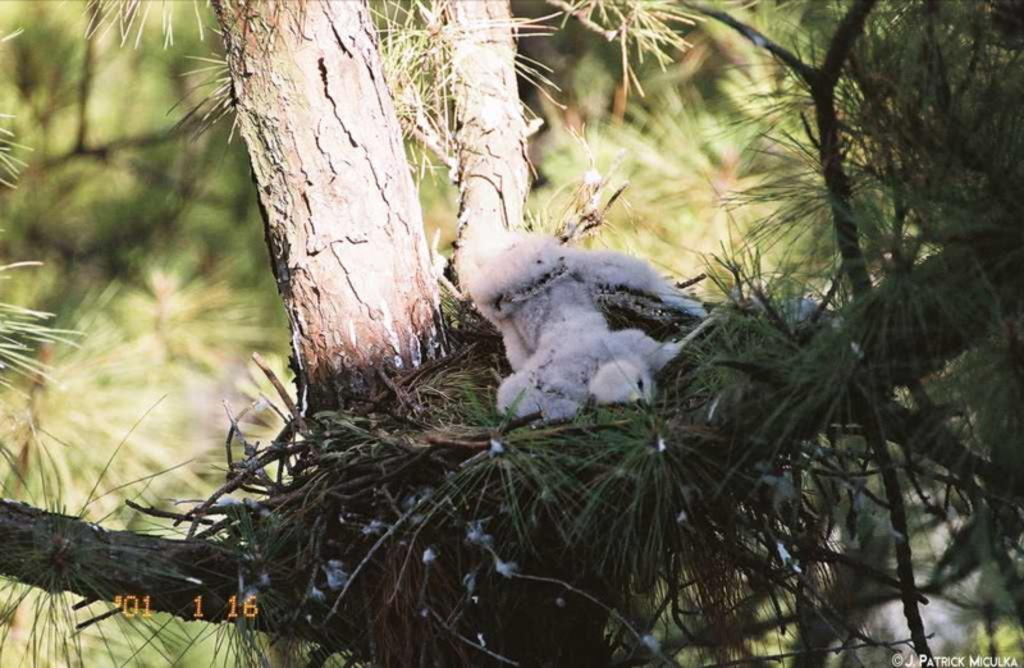What animal can be seen in the image? There is a chick in the image. Where is the chick located? The chick is on a nest. What is the nest resting on? The nest is on a branch of a tree. How would you describe the background of the image? The background of the image is blurred. Are there any visible marks on the image? Yes, there are watermarks on the image. What is the plot of the story being told in the image? The image does not depict a story or plot; it is a still photograph of a chick on a nest. 